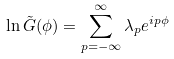<formula> <loc_0><loc_0><loc_500><loc_500>\ln \tilde { G } ( \phi ) = \sum _ { p = - \infty } ^ { \infty } \lambda _ { p } e ^ { i p \phi }</formula> 